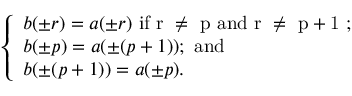Convert formula to latex. <formula><loc_0><loc_0><loc_500><loc_500>\left \{ \begin{array} { l } { b ( \pm r ) = a ( \pm r ) i f r \neq p a n d r \neq p + 1 ; } \\ { b ( \pm p ) = a ( \pm ( p + 1 ) ) ; a n d } \\ { b ( \pm ( p + 1 ) ) = a ( \pm p ) . } \end{array}</formula> 